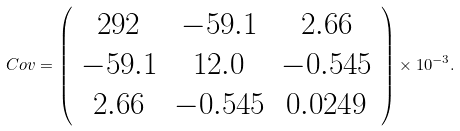<formula> <loc_0><loc_0><loc_500><loc_500>C o v = \left ( \begin{array} { c c c } 2 9 2 & - 5 9 . 1 & 2 . 6 6 \\ - 5 9 . 1 & 1 2 . 0 & - 0 . 5 4 5 \\ 2 . 6 6 & - 0 . 5 4 5 & 0 . 0 2 4 9 \end{array} \right ) \times 1 0 ^ { - 3 } .</formula> 